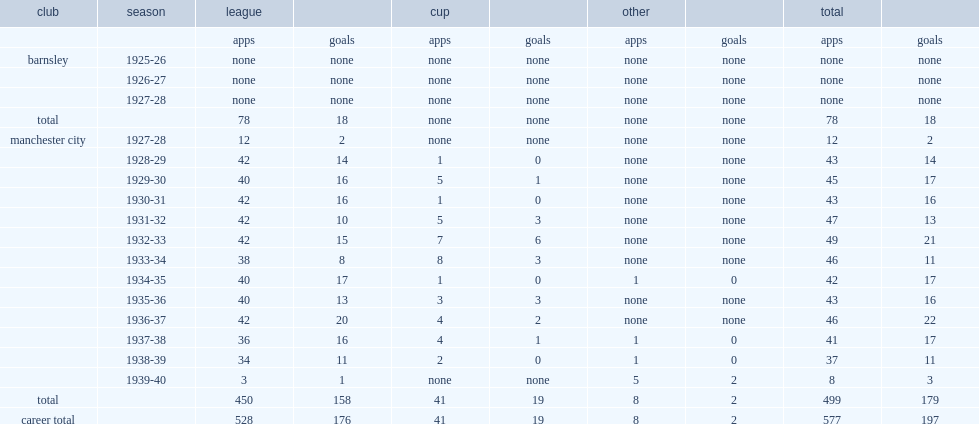How many league goals did brook score for manchester city totally? 158.0. 